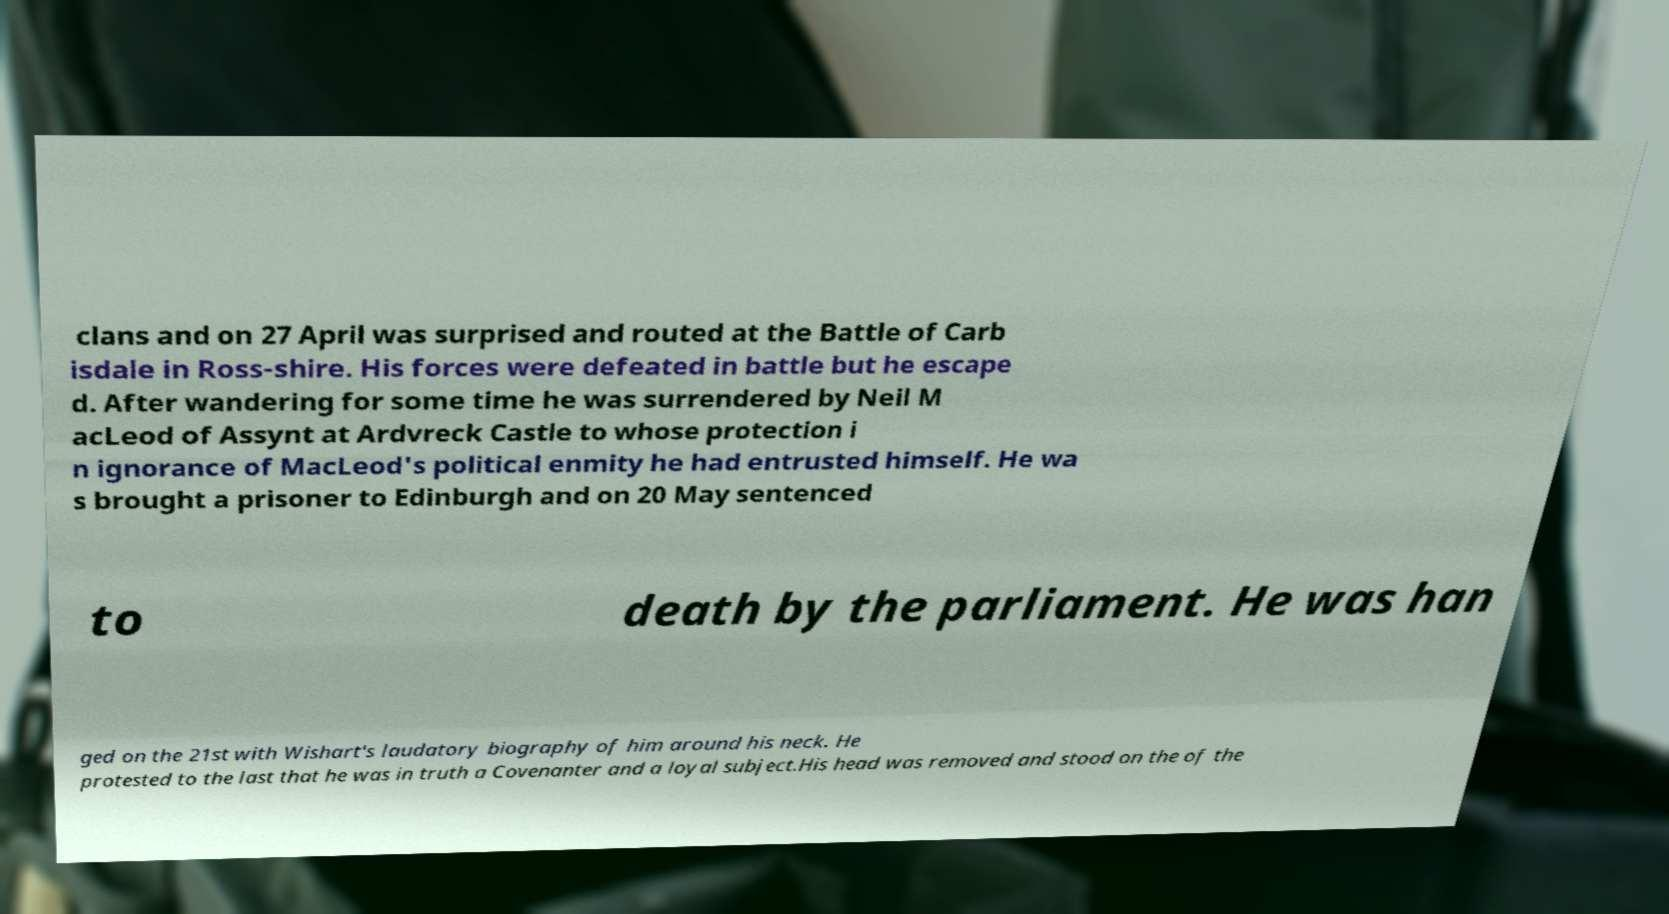Can you read and provide the text displayed in the image?This photo seems to have some interesting text. Can you extract and type it out for me? clans and on 27 April was surprised and routed at the Battle of Carb isdale in Ross-shire. His forces were defeated in battle but he escape d. After wandering for some time he was surrendered by Neil M acLeod of Assynt at Ardvreck Castle to whose protection i n ignorance of MacLeod's political enmity he had entrusted himself. He wa s brought a prisoner to Edinburgh and on 20 May sentenced to death by the parliament. He was han ged on the 21st with Wishart's laudatory biography of him around his neck. He protested to the last that he was in truth a Covenanter and a loyal subject.His head was removed and stood on the of the 